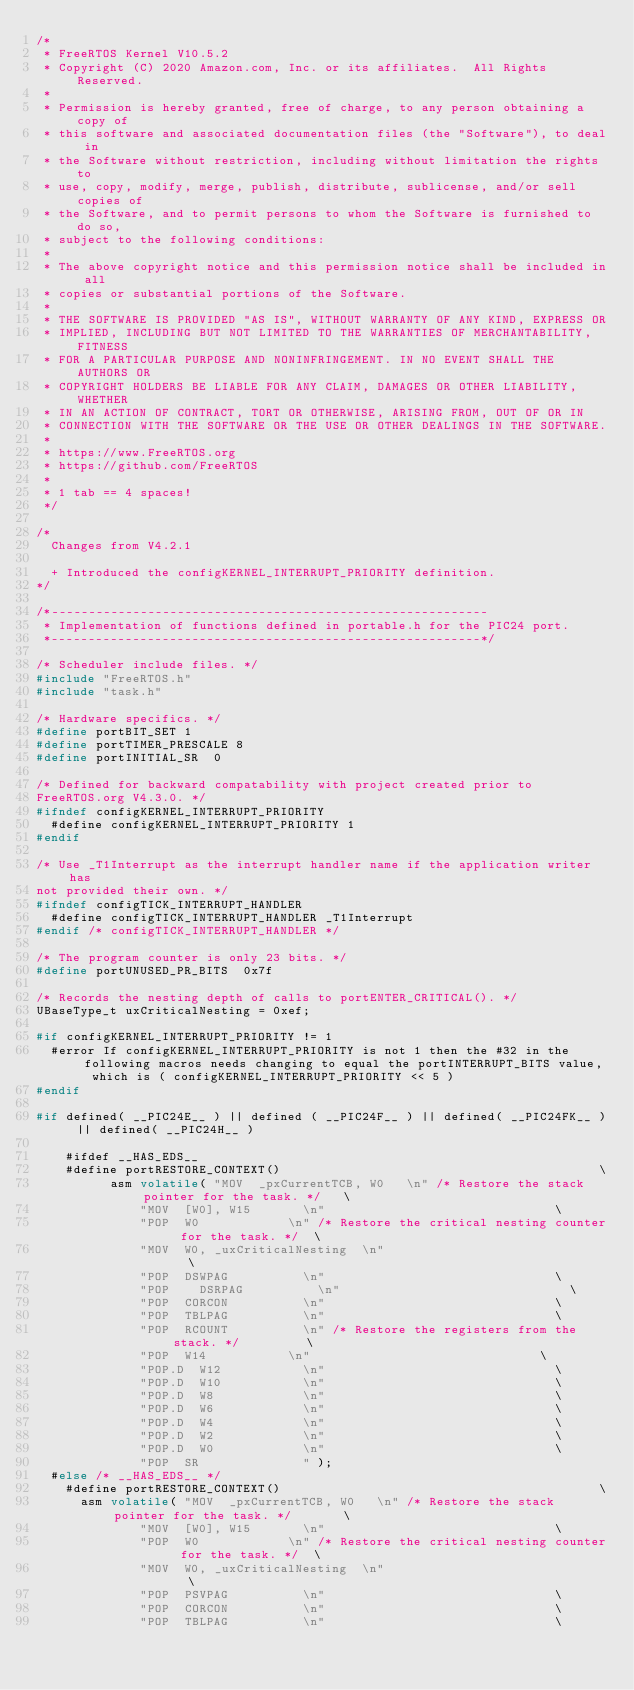Convert code to text. <code><loc_0><loc_0><loc_500><loc_500><_C_>/*
 * FreeRTOS Kernel V10.5.2
 * Copyright (C) 2020 Amazon.com, Inc. or its affiliates.  All Rights Reserved.
 *
 * Permission is hereby granted, free of charge, to any person obtaining a copy of
 * this software and associated documentation files (the "Software"), to deal in
 * the Software without restriction, including without limitation the rights to
 * use, copy, modify, merge, publish, distribute, sublicense, and/or sell copies of
 * the Software, and to permit persons to whom the Software is furnished to do so,
 * subject to the following conditions:
 *
 * The above copyright notice and this permission notice shall be included in all
 * copies or substantial portions of the Software.
 *
 * THE SOFTWARE IS PROVIDED "AS IS", WITHOUT WARRANTY OF ANY KIND, EXPRESS OR
 * IMPLIED, INCLUDING BUT NOT LIMITED TO THE WARRANTIES OF MERCHANTABILITY, FITNESS
 * FOR A PARTICULAR PURPOSE AND NONINFRINGEMENT. IN NO EVENT SHALL THE AUTHORS OR
 * COPYRIGHT HOLDERS BE LIABLE FOR ANY CLAIM, DAMAGES OR OTHER LIABILITY, WHETHER
 * IN AN ACTION OF CONTRACT, TORT OR OTHERWISE, ARISING FROM, OUT OF OR IN
 * CONNECTION WITH THE SOFTWARE OR THE USE OR OTHER DEALINGS IN THE SOFTWARE.
 *
 * https://www.FreeRTOS.org
 * https://github.com/FreeRTOS
 *
 * 1 tab == 4 spaces!
 */

/*
	Changes from V4.2.1

	+ Introduced the configKERNEL_INTERRUPT_PRIORITY definition.
*/

/*-----------------------------------------------------------
 * Implementation of functions defined in portable.h for the PIC24 port.
 *----------------------------------------------------------*/

/* Scheduler include files. */
#include "FreeRTOS.h"
#include "task.h"

/* Hardware specifics. */
#define portBIT_SET 1
#define portTIMER_PRESCALE 8
#define portINITIAL_SR	0

/* Defined for backward compatability with project created prior to
FreeRTOS.org V4.3.0. */
#ifndef configKERNEL_INTERRUPT_PRIORITY
	#define configKERNEL_INTERRUPT_PRIORITY 1
#endif

/* Use _T1Interrupt as the interrupt handler name if the application writer has
not provided their own. */
#ifndef configTICK_INTERRUPT_HANDLER
	#define configTICK_INTERRUPT_HANDLER _T1Interrupt
#endif /* configTICK_INTERRUPT_HANDLER */

/* The program counter is only 23 bits. */
#define portUNUSED_PR_BITS	0x7f

/* Records the nesting depth of calls to portENTER_CRITICAL(). */
UBaseType_t uxCriticalNesting = 0xef;

#if configKERNEL_INTERRUPT_PRIORITY != 1
	#error If configKERNEL_INTERRUPT_PRIORITY is not 1 then the #32 in the following macros needs changing to equal the portINTERRUPT_BITS value, which is ( configKERNEL_INTERRUPT_PRIORITY << 5 )
#endif

#if defined( __PIC24E__ ) || defined ( __PIC24F__ ) || defined( __PIC24FK__ ) || defined( __PIC24H__ )

    #ifdef __HAS_EDS__
		#define portRESTORE_CONTEXT()																						\
					asm volatile(	"MOV	_pxCurrentTCB, W0		\n"	/* Restore the stack pointer for the task. */		\
							"MOV	[W0], W15				\n"																\
							"POP	W0						\n"	/* Restore the critical nesting counter for the task. */	\
							"MOV	W0, _uxCriticalNesting	\n"																\
							"POP	DSWPAG					\n"																\
							"POP    DSRPAG					\n"																\
							"POP	CORCON					\n"																\
							"POP	TBLPAG					\n"																\
							"POP	RCOUNT					\n"	/* Restore the registers from the stack. */					\
							"POP	W14						\n"																\
							"POP.D	W12						\n"																\
							"POP.D	W10						\n"																\
							"POP.D	W8						\n"																\
							"POP.D	W6						\n"																\
							"POP.D	W4						\n"																\
							"POP.D	W2						\n"																\
							"POP.D	W0						\n"																\
							"POP	SR						  " );
	#else /* __HAS_EDS__ */
		#define portRESTORE_CONTEXT()																						\
			asm volatile(	"MOV	_pxCurrentTCB, W0		\n"	/* Restore the stack pointer for the task. */				\
							"MOV	[W0], W15				\n"																\
							"POP	W0						\n"	/* Restore the critical nesting counter for the task. */	\
							"MOV	W0, _uxCriticalNesting	\n"																\
							"POP	PSVPAG					\n"																\
							"POP	CORCON					\n"																\
							"POP	TBLPAG					\n"																\</code> 